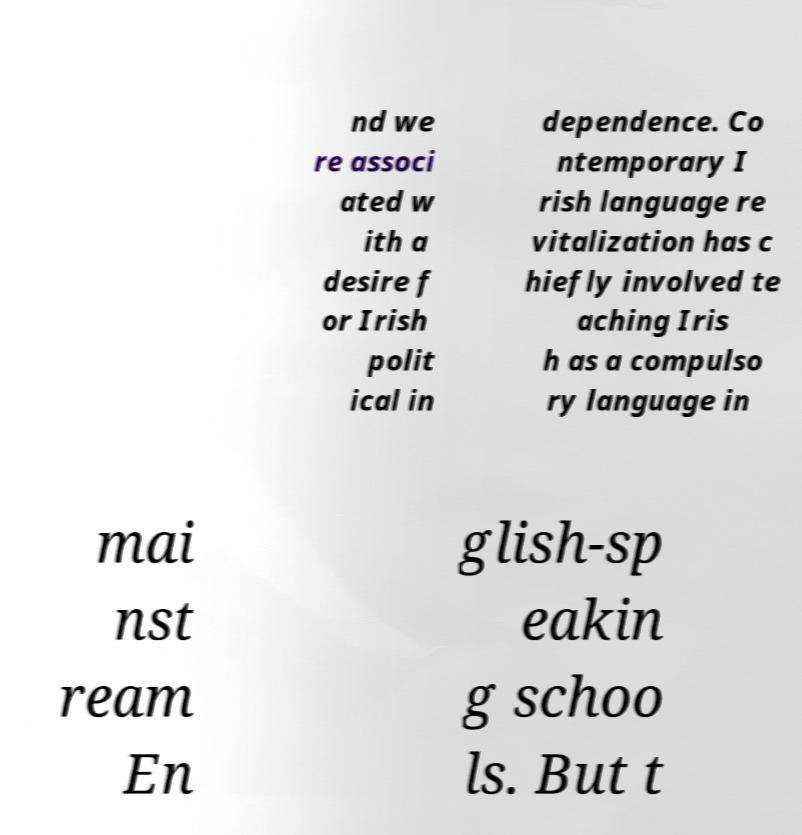I need the written content from this picture converted into text. Can you do that? nd we re associ ated w ith a desire f or Irish polit ical in dependence. Co ntemporary I rish language re vitalization has c hiefly involved te aching Iris h as a compulso ry language in mai nst ream En glish-sp eakin g schoo ls. But t 